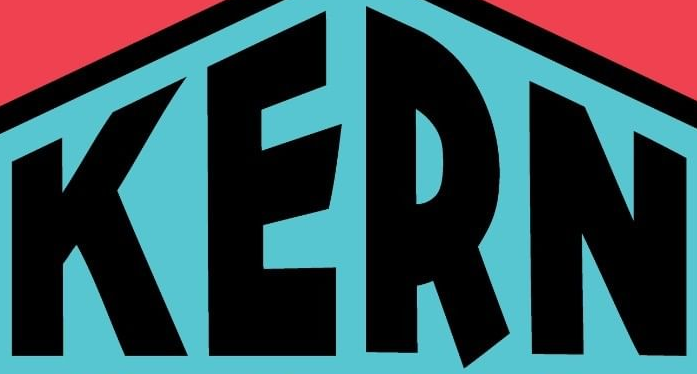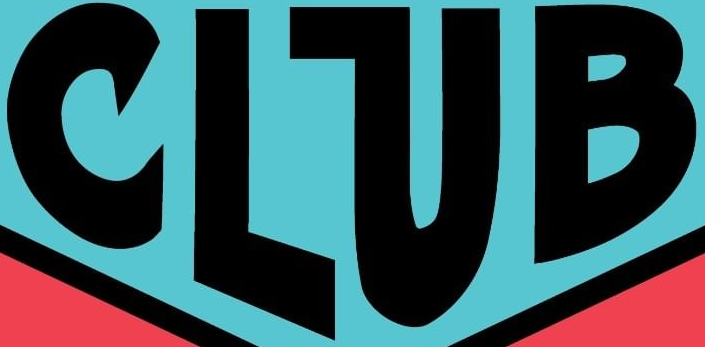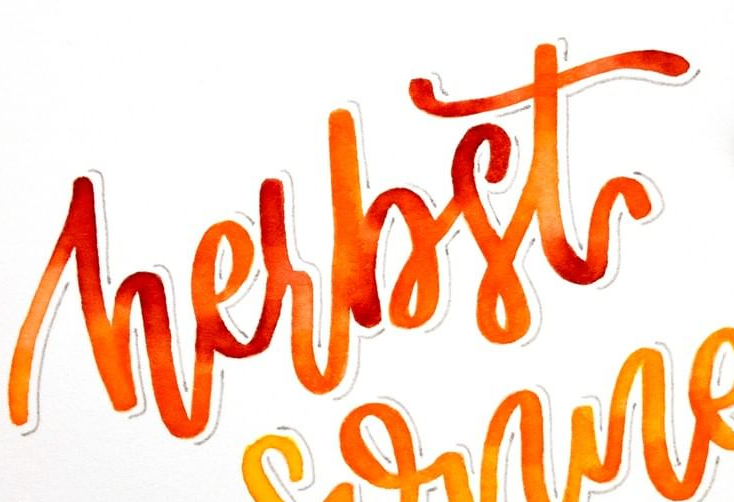What text is displayed in these images sequentially, separated by a semicolon? KERN; CLUB; hesbst 